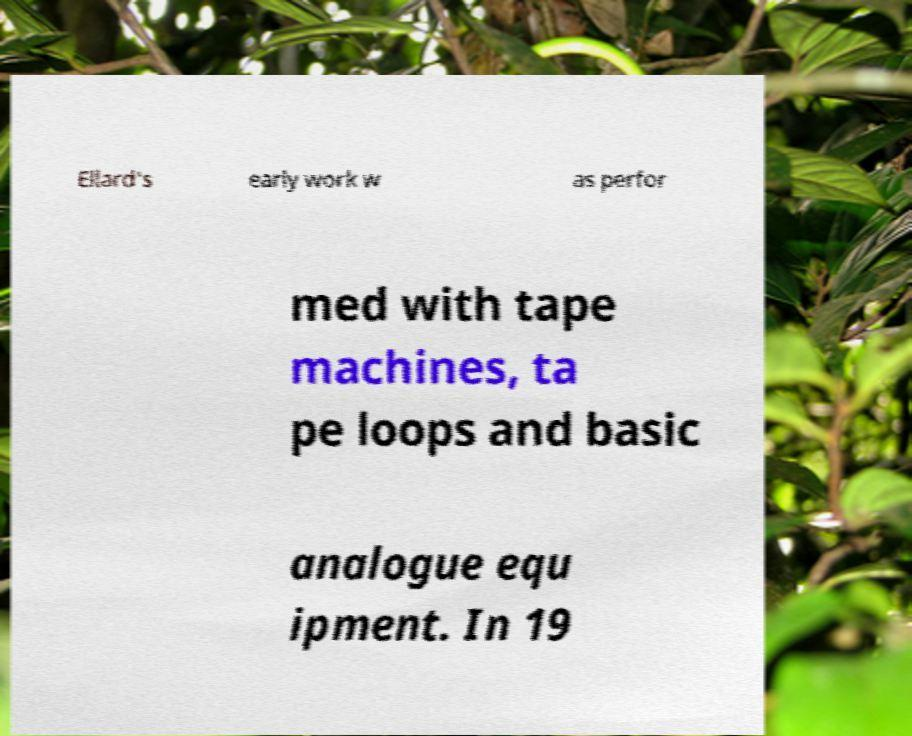What messages or text are displayed in this image? I need them in a readable, typed format. Ellard's early work w as perfor med with tape machines, ta pe loops and basic analogue equ ipment. In 19 